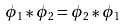<formula> <loc_0><loc_0><loc_500><loc_500>\phi _ { 1 } * \phi _ { 2 } = \phi _ { 2 } * \phi _ { 1 }</formula> 